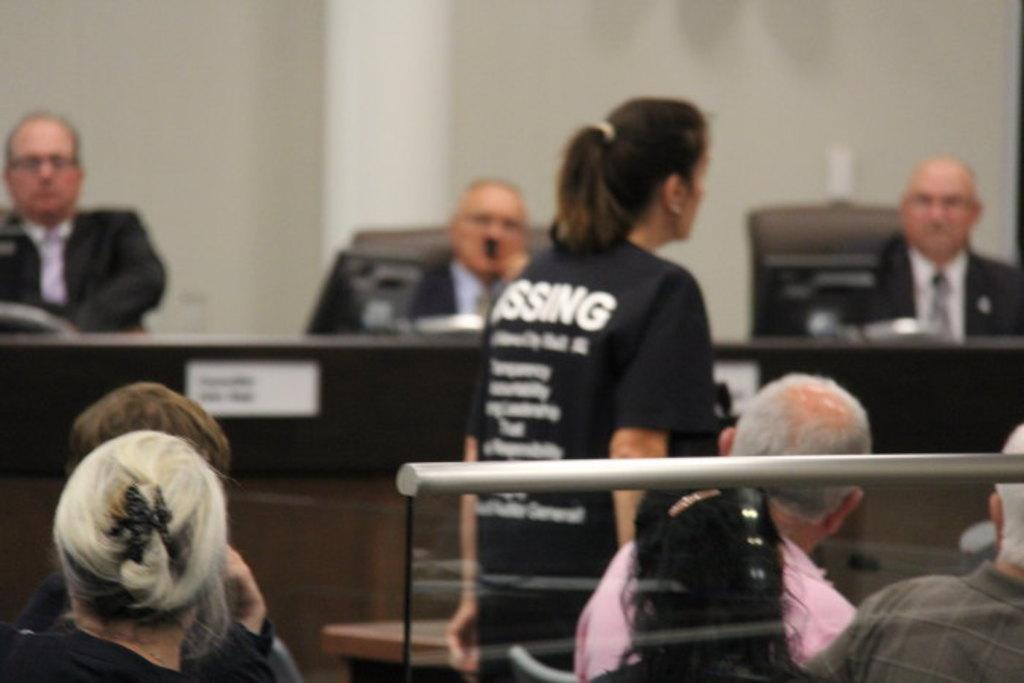What type of setting is depicted in the image? The image appears to depict an office setting. What are the people in the image doing? There are people sitting on chairs in the image, and three men are sitting in front of systems. Is there any movement or activity happening in the image? Yes, there is a woman walking in the area. What type of hate can be seen on the faces of the people in the image? There is no indication of hate or any negative emotions on the faces of the people in the image. Can you tell me how many airports are visible in the image? There are no airports present in the image; it depicts an office setting. 